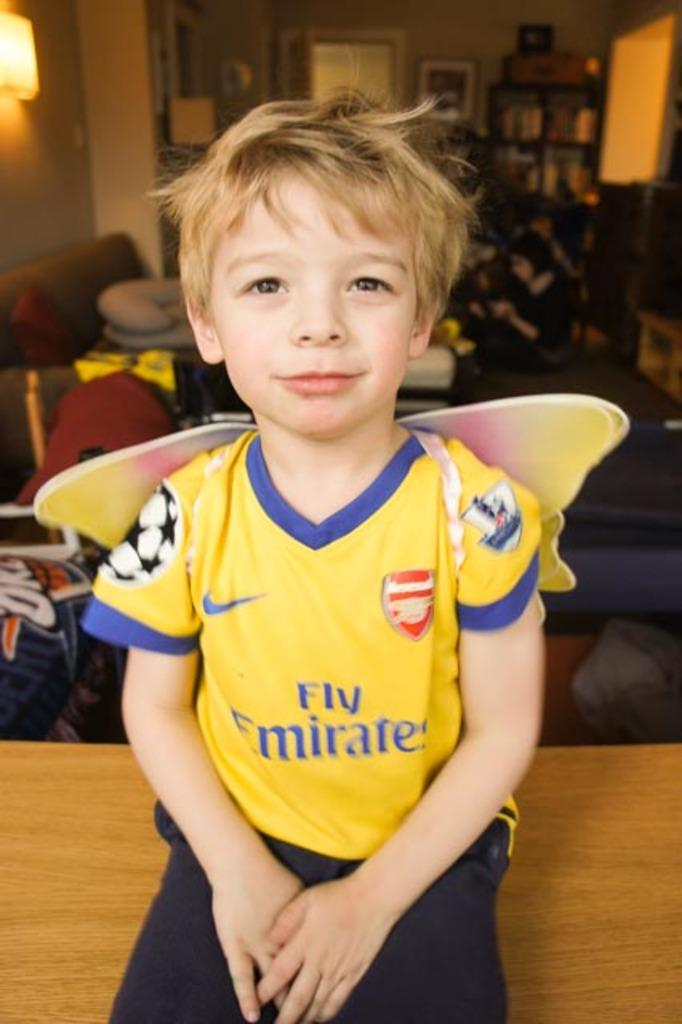<image>
Write a terse but informative summary of the picture. boy wearing a yellow fly emerates soccer jersey 